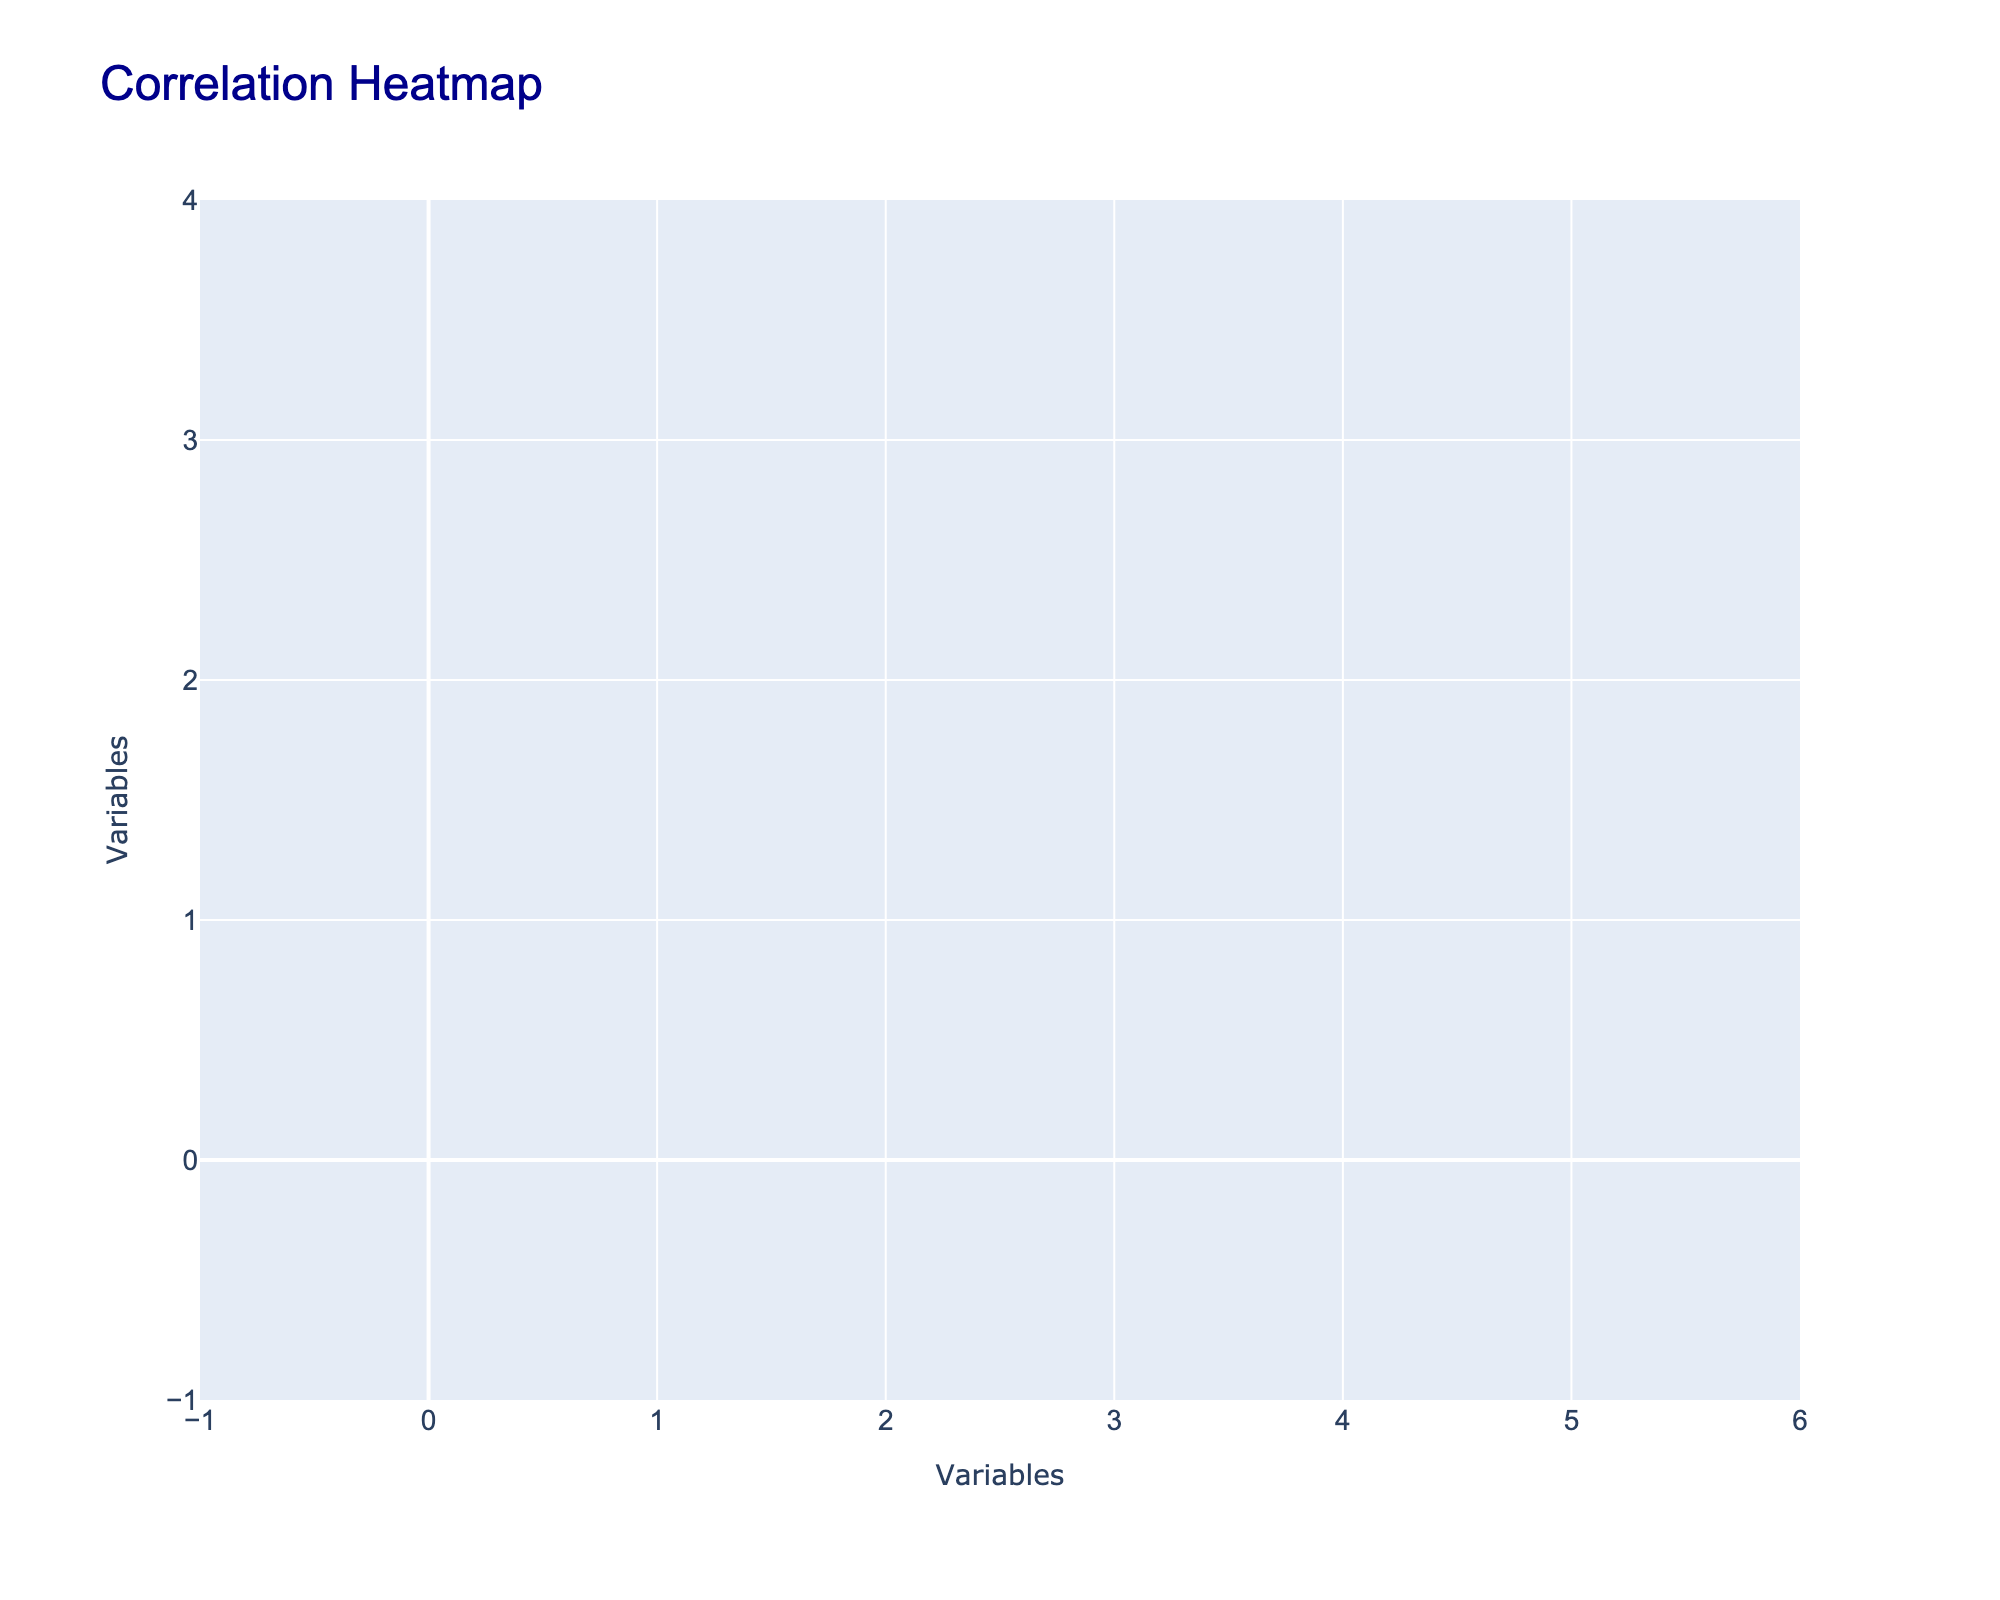What is the correlation between socio-economic status and healthcare accessibility? Based on the data, we can evaluate the correlation between socio-economic status and healthcare accessibility. If we assign numerical values (High=2, Medium=1, Low=0) and accessibility levels (Excellent=2, Good=1, Fair=0.5, Poor=0), we can compute the correlation coefficient from the correlation matrix.
Answer: Strong positive correlation Is there a correlation between health insurance coverage and employment status? To determine the correlation, we can assign numerical values (Employed=1, Unemployed=0) for employment status and (Yes=1, No=0) for health insurance coverage. Analyzing the data reveals that a strong relationship exists between being employed and having health insurance coverage as indicated in the correlation matrix.
Answer: Yes What percentage of individuals with high socio-economic status have excellent healthcare accessibility? Out of the data points for individuals with high socio-economic status (3 total), 2 have excellent healthcare accessibility. Thus, the percentage is calculated as (2/3) * 100 = 66.67%.
Answer: Approximately 67% What is the average level of healthcare accessibility for those with medium socio-economic status? The individuals with medium socio-economic status have accessibility levels of Good, Fair, and Good again. To calculate the average, we assign values (Good=1, Fair=0.5). Therefore, the average is (1 + 0.5 + 1) / 3 = 0.83.
Answer: 0.83 Is it true that all unemployed individuals have poor healthcare accessibility? By examining the data, we find that out of the unemployed individuals, while some have Fair healthcare accessibility, none have access that is labeled as Excellent or Good, and thus it holds to say that all have either Fair or Poor. However, not all show Poor specifically. Therefore, the answer is no.
Answer: No What is the correlation between education level and employment status for those with low socio-economic status? To analyze this, we assess the individuals with low socio-economic status who have Middle School education and notice they are also unemployed. Since they lack a higher education level and employment stats, the correlation appears to be negative.
Answer: Negative correlation How many individuals in the dataset have health insurance coverage? From the dataset, we can tally the number of individuals who have health insurance coverage (Yes). There are a total of 5 individuals out of the 10 in the dataset who have health insurance.
Answer: 5 What is the difference in healthcare accessibility between high and low socio-economic status categories? To find the difference, we average the healthcare accessibility rankings for high socio-economic status (2 + 1) / 2 = 1.5 and for low socio-economic status (0 + 0) / 2 = 0. The difference would then be 1.5 - 0 = 1.5
Answer: 1.5 